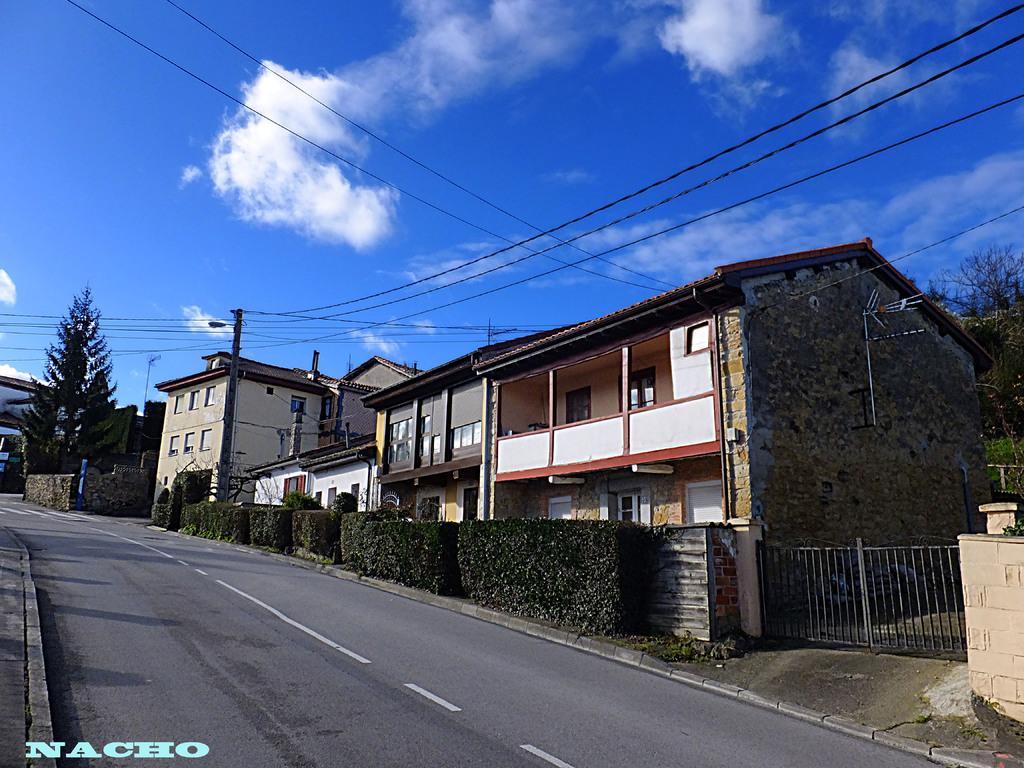In one or two sentences, can you explain what this image depicts? In this image we can see a group of buildings with windows and doors. In the center of the image we can see some plants. On the right side of the image we can see a gate. In the background, we can see a group of trees and the cloudy sky 